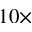<formula> <loc_0><loc_0><loc_500><loc_500>1 0 \times</formula> 